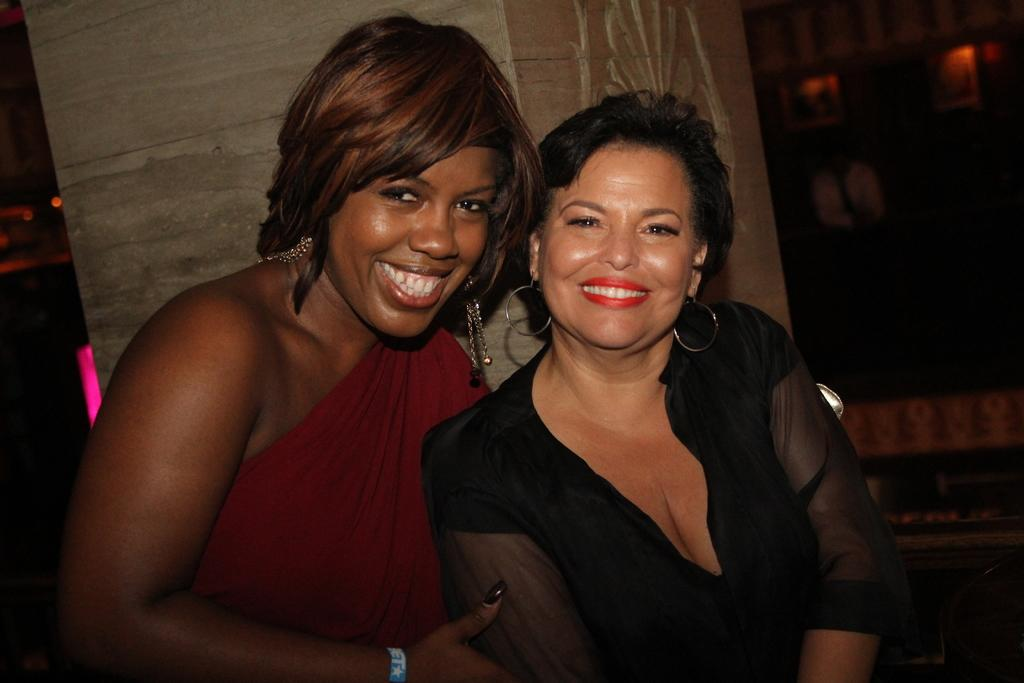Who is present in the image? There are women in the image. What are the women doing in the image? The women are sitting and smiling. What can be seen in the background of the image? There is a pillar in the background of the image. What type of island can be seen in the background of the image? There is no island present in the image; it features women sitting and smiling with a pillar in the background. 